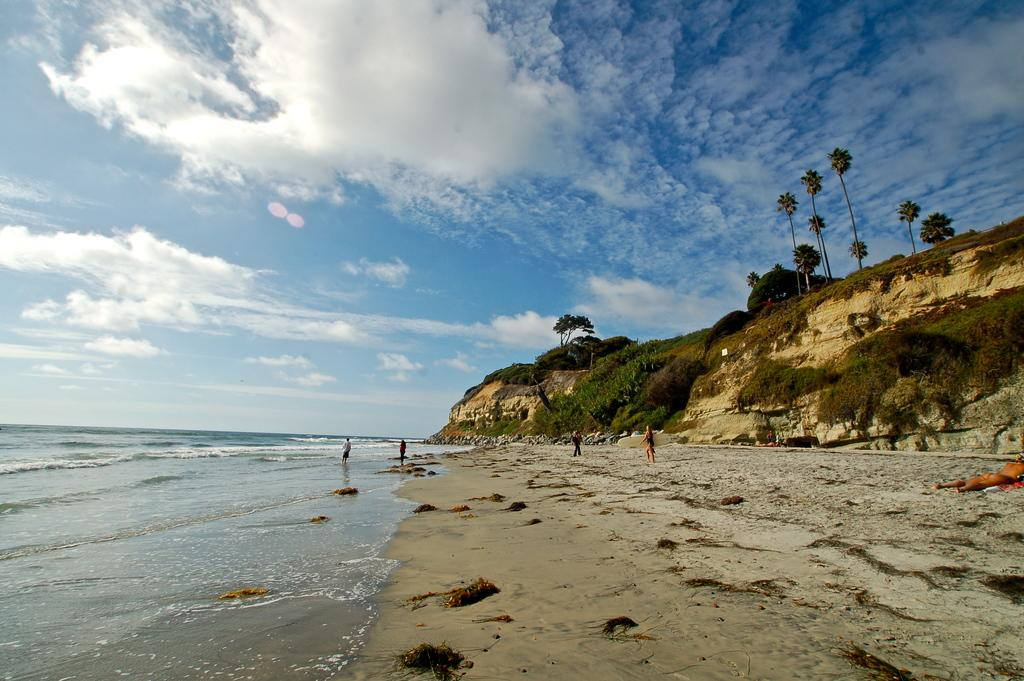What is the main setting of the image? The main setting of the image is the seashore, where a group of people is present. What is the large water body visible in the image? The large water body is the sea, which is adjacent to the seashore. What type of vegetation can be seen in the image? There is a group of trees and plants on a hill in the image. What is the condition of the sky in the image? The sky appears cloudy in the image. What type of apparatus is being used to blow up the balloons in the image? There are no balloons or apparatus present in the image; it features a group of people on the seashore with a large water body, a group of trees, plants on a hill, and a cloudy sky. 